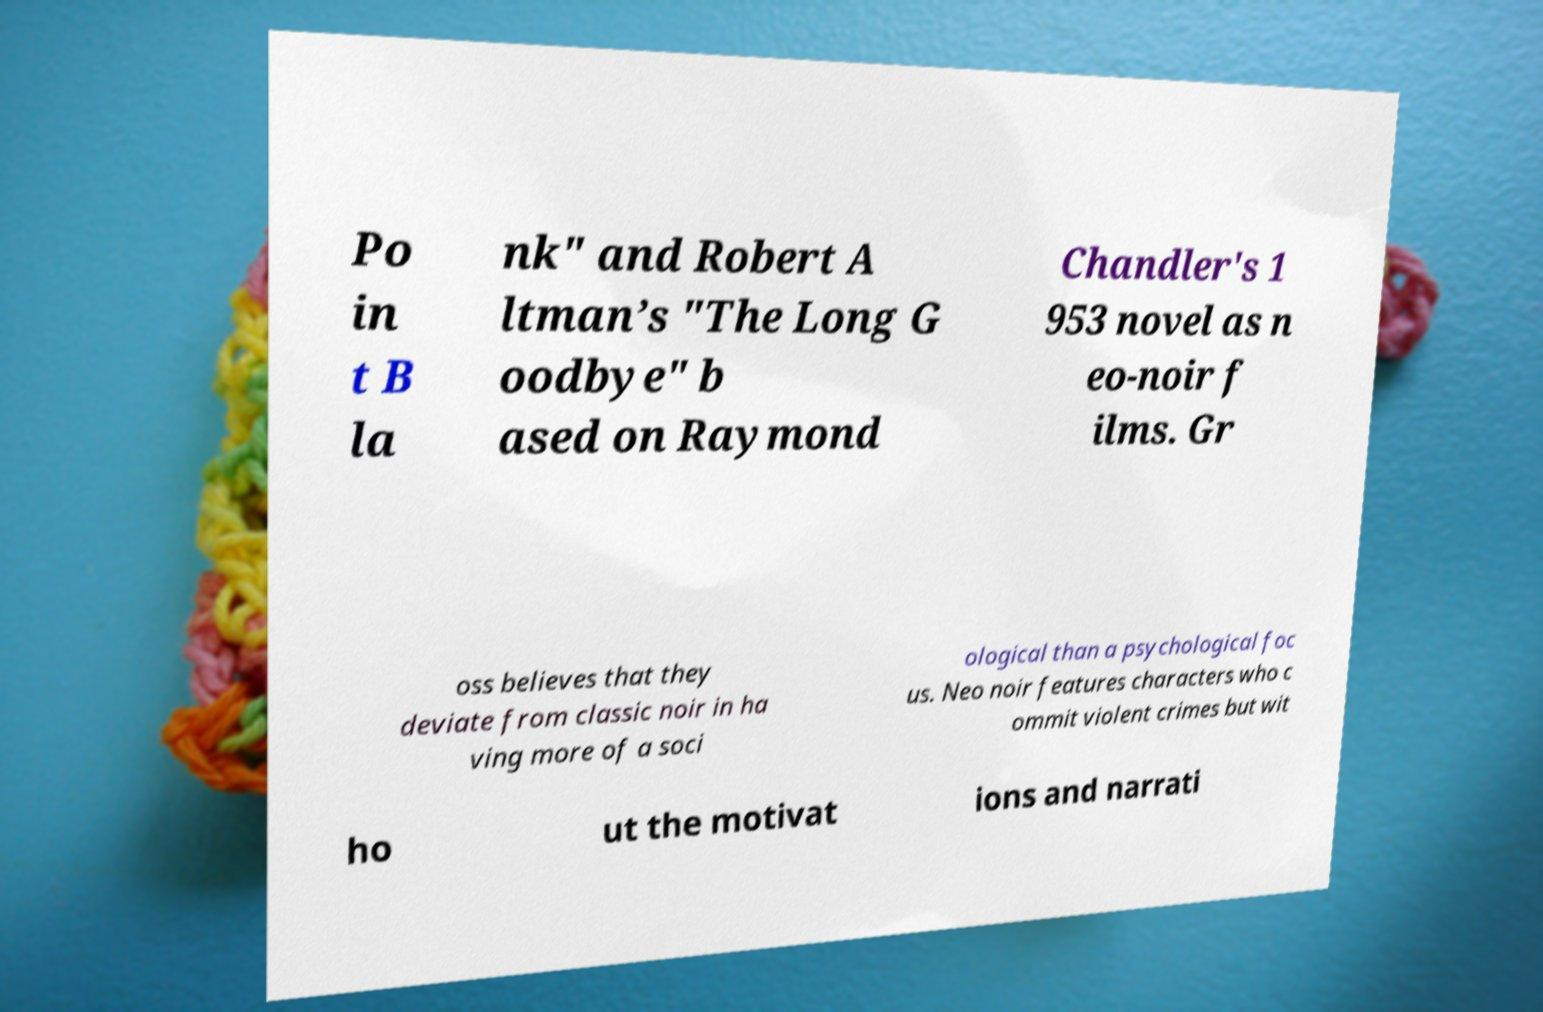Could you extract and type out the text from this image? Po in t B la nk" and Robert A ltman’s "The Long G oodbye" b ased on Raymond Chandler's 1 953 novel as n eo-noir f ilms. Gr oss believes that they deviate from classic noir in ha ving more of a soci ological than a psychological foc us. Neo noir features characters who c ommit violent crimes but wit ho ut the motivat ions and narrati 